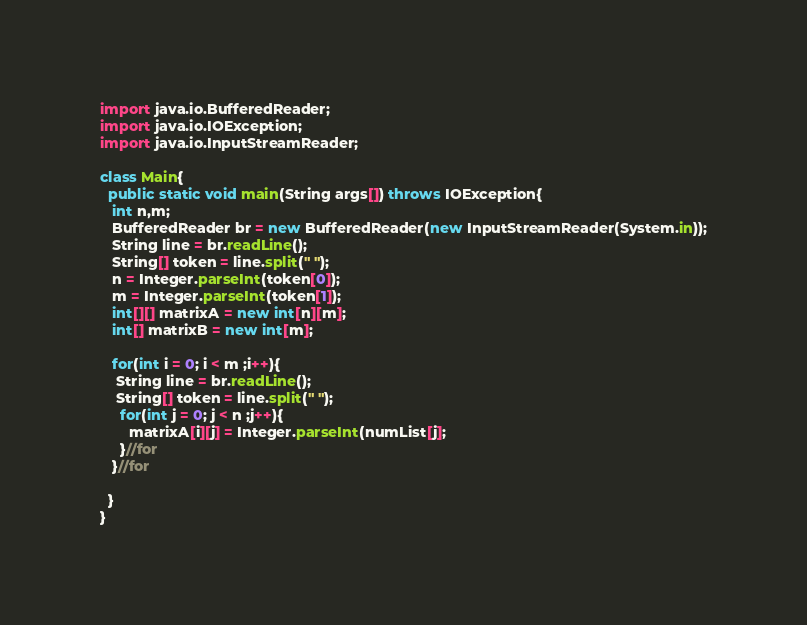Convert code to text. <code><loc_0><loc_0><loc_500><loc_500><_Java_>import java.io.BufferedReader;
import java.io.IOException;
import java.io.InputStreamReader;

class Main{
  public static void main(String args[]) throws IOException{
   int n,m;
   BufferedReader br = new BufferedReader(new InputStreamReader(System.in));
   String line = br.readLine(); 
   String[] token = line.split(" ");
   n = Integer.parseInt(token[0]);
   m = Integer.parseInt(token[1]);
   int[][] matrixA = new int[n][m];
   int[] matrixB = new int[m];

   for(int i = 0; i < m ;i++){
    String line = br.readLine(); 
    String[] token = line.split(" ");
     for(int j = 0; j < n ;j++){
       matrixA[i][j] = Integer.parseInt(numList[j];
     }//for  
   }//for
   
  }
}</code> 